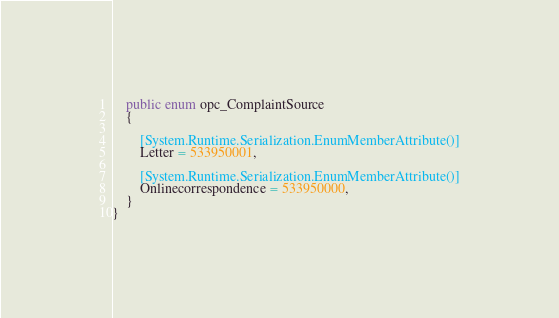<code> <loc_0><loc_0><loc_500><loc_500><_C#_>	public enum opc_ComplaintSource
	{
		
		[System.Runtime.Serialization.EnumMemberAttribute()]
		Letter = 533950001,
		
		[System.Runtime.Serialization.EnumMemberAttribute()]
		Onlinecorrespondence = 533950000,
	}
}</code> 